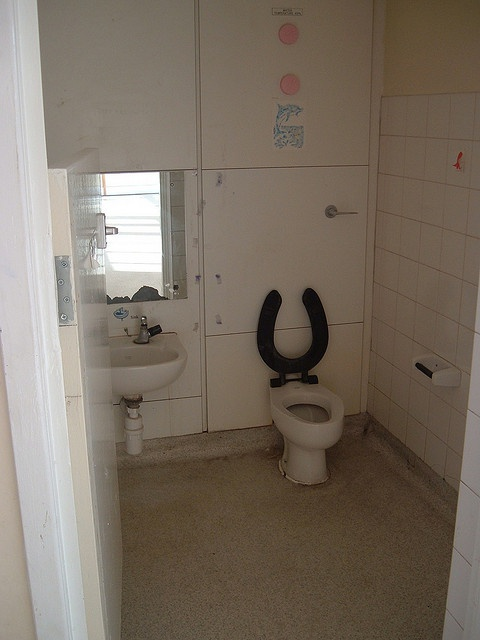Describe the objects in this image and their specific colors. I can see toilet in darkgray, black, gray, and maroon tones and sink in darkgray, gray, and black tones in this image. 